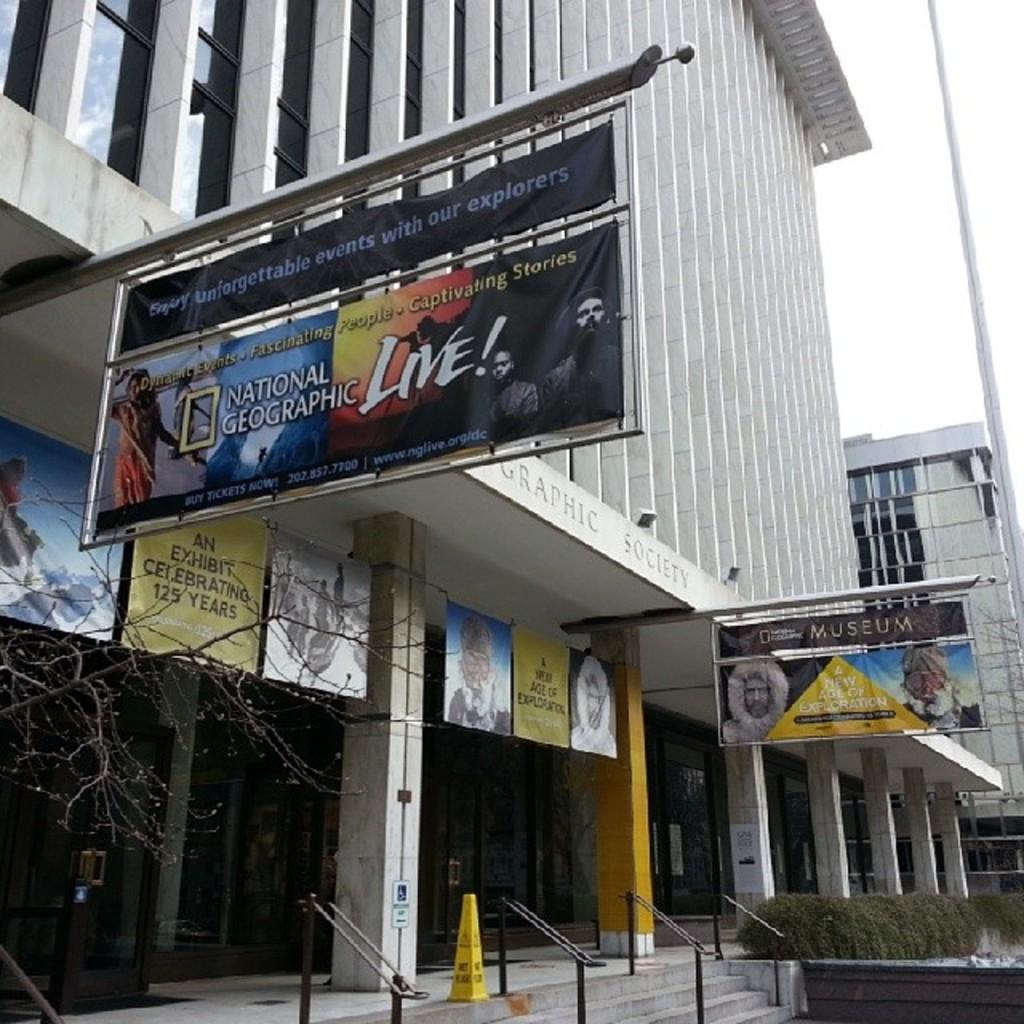What television channel is being advertised on the sign?
Your response must be concise. National geographic. Do they have captivating stories?
Make the answer very short. Yes. 